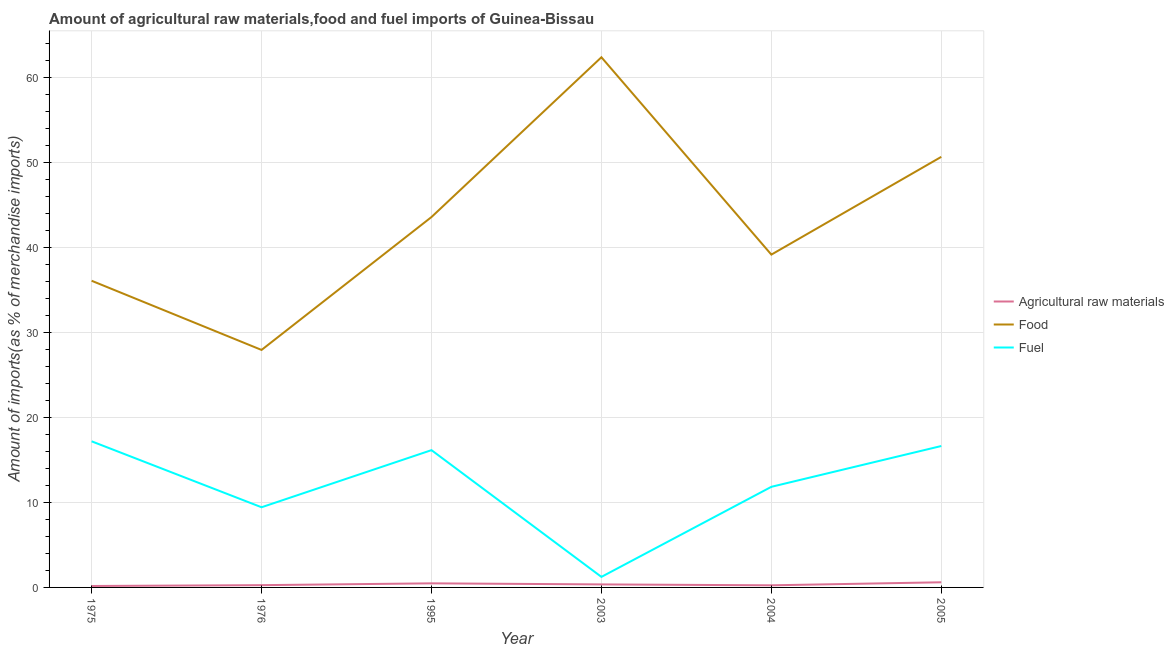How many different coloured lines are there?
Offer a terse response. 3. What is the percentage of food imports in 2004?
Make the answer very short. 39.18. Across all years, what is the maximum percentage of raw materials imports?
Ensure brevity in your answer.  0.61. Across all years, what is the minimum percentage of raw materials imports?
Make the answer very short. 0.17. What is the total percentage of food imports in the graph?
Your response must be concise. 259.96. What is the difference between the percentage of food imports in 1976 and that in 2004?
Offer a very short reply. -11.22. What is the difference between the percentage of fuel imports in 2005 and the percentage of raw materials imports in 1976?
Your response must be concise. 16.38. What is the average percentage of raw materials imports per year?
Give a very brief answer. 0.35. In the year 2003, what is the difference between the percentage of raw materials imports and percentage of fuel imports?
Provide a succinct answer. -0.89. In how many years, is the percentage of raw materials imports greater than 10 %?
Your answer should be compact. 0. What is the ratio of the percentage of raw materials imports in 1975 to that in 2003?
Offer a very short reply. 0.48. Is the percentage of fuel imports in 1976 less than that in 2004?
Offer a terse response. Yes. Is the difference between the percentage of raw materials imports in 1976 and 2004 greater than the difference between the percentage of fuel imports in 1976 and 2004?
Make the answer very short. Yes. What is the difference between the highest and the second highest percentage of food imports?
Provide a short and direct response. 11.72. What is the difference between the highest and the lowest percentage of fuel imports?
Your answer should be very brief. 15.96. Is it the case that in every year, the sum of the percentage of raw materials imports and percentage of food imports is greater than the percentage of fuel imports?
Offer a terse response. Yes. How many years are there in the graph?
Keep it short and to the point. 6. Are the values on the major ticks of Y-axis written in scientific E-notation?
Your answer should be compact. No. Does the graph contain grids?
Make the answer very short. Yes. How many legend labels are there?
Provide a succinct answer. 3. How are the legend labels stacked?
Your answer should be very brief. Vertical. What is the title of the graph?
Keep it short and to the point. Amount of agricultural raw materials,food and fuel imports of Guinea-Bissau. What is the label or title of the X-axis?
Offer a terse response. Year. What is the label or title of the Y-axis?
Keep it short and to the point. Amount of imports(as % of merchandise imports). What is the Amount of imports(as % of merchandise imports) in Agricultural raw materials in 1975?
Offer a very short reply. 0.17. What is the Amount of imports(as % of merchandise imports) of Food in 1975?
Keep it short and to the point. 36.1. What is the Amount of imports(as % of merchandise imports) in Fuel in 1975?
Offer a very short reply. 17.2. What is the Amount of imports(as % of merchandise imports) of Agricultural raw materials in 1976?
Provide a short and direct response. 0.27. What is the Amount of imports(as % of merchandise imports) of Food in 1976?
Provide a short and direct response. 27.96. What is the Amount of imports(as % of merchandise imports) in Fuel in 1976?
Make the answer very short. 9.44. What is the Amount of imports(as % of merchandise imports) of Agricultural raw materials in 1995?
Provide a succinct answer. 0.48. What is the Amount of imports(as % of merchandise imports) in Food in 1995?
Ensure brevity in your answer.  43.6. What is the Amount of imports(as % of merchandise imports) of Fuel in 1995?
Provide a short and direct response. 16.16. What is the Amount of imports(as % of merchandise imports) of Agricultural raw materials in 2003?
Give a very brief answer. 0.36. What is the Amount of imports(as % of merchandise imports) in Food in 2003?
Make the answer very short. 62.42. What is the Amount of imports(as % of merchandise imports) of Fuel in 2003?
Provide a succinct answer. 1.24. What is the Amount of imports(as % of merchandise imports) of Agricultural raw materials in 2004?
Offer a terse response. 0.25. What is the Amount of imports(as % of merchandise imports) of Food in 2004?
Offer a very short reply. 39.18. What is the Amount of imports(as % of merchandise imports) of Fuel in 2004?
Give a very brief answer. 11.84. What is the Amount of imports(as % of merchandise imports) of Agricultural raw materials in 2005?
Your answer should be compact. 0.61. What is the Amount of imports(as % of merchandise imports) in Food in 2005?
Provide a succinct answer. 50.69. What is the Amount of imports(as % of merchandise imports) of Fuel in 2005?
Give a very brief answer. 16.65. Across all years, what is the maximum Amount of imports(as % of merchandise imports) in Agricultural raw materials?
Offer a very short reply. 0.61. Across all years, what is the maximum Amount of imports(as % of merchandise imports) in Food?
Your answer should be compact. 62.42. Across all years, what is the maximum Amount of imports(as % of merchandise imports) in Fuel?
Offer a terse response. 17.2. Across all years, what is the minimum Amount of imports(as % of merchandise imports) of Agricultural raw materials?
Provide a succinct answer. 0.17. Across all years, what is the minimum Amount of imports(as % of merchandise imports) of Food?
Make the answer very short. 27.96. Across all years, what is the minimum Amount of imports(as % of merchandise imports) in Fuel?
Ensure brevity in your answer.  1.24. What is the total Amount of imports(as % of merchandise imports) of Agricultural raw materials in the graph?
Your answer should be very brief. 2.13. What is the total Amount of imports(as % of merchandise imports) of Food in the graph?
Your response must be concise. 259.96. What is the total Amount of imports(as % of merchandise imports) of Fuel in the graph?
Provide a short and direct response. 72.54. What is the difference between the Amount of imports(as % of merchandise imports) of Agricultural raw materials in 1975 and that in 1976?
Offer a terse response. -0.1. What is the difference between the Amount of imports(as % of merchandise imports) in Food in 1975 and that in 1976?
Your answer should be very brief. 8.14. What is the difference between the Amount of imports(as % of merchandise imports) of Fuel in 1975 and that in 1976?
Your answer should be compact. 7.76. What is the difference between the Amount of imports(as % of merchandise imports) in Agricultural raw materials in 1975 and that in 1995?
Your answer should be compact. -0.31. What is the difference between the Amount of imports(as % of merchandise imports) in Food in 1975 and that in 1995?
Provide a succinct answer. -7.5. What is the difference between the Amount of imports(as % of merchandise imports) of Fuel in 1975 and that in 1995?
Ensure brevity in your answer.  1.04. What is the difference between the Amount of imports(as % of merchandise imports) in Agricultural raw materials in 1975 and that in 2003?
Offer a very short reply. -0.19. What is the difference between the Amount of imports(as % of merchandise imports) in Food in 1975 and that in 2003?
Your response must be concise. -26.31. What is the difference between the Amount of imports(as % of merchandise imports) of Fuel in 1975 and that in 2003?
Offer a very short reply. 15.96. What is the difference between the Amount of imports(as % of merchandise imports) of Agricultural raw materials in 1975 and that in 2004?
Provide a succinct answer. -0.08. What is the difference between the Amount of imports(as % of merchandise imports) in Food in 1975 and that in 2004?
Give a very brief answer. -3.08. What is the difference between the Amount of imports(as % of merchandise imports) in Fuel in 1975 and that in 2004?
Provide a short and direct response. 5.36. What is the difference between the Amount of imports(as % of merchandise imports) of Agricultural raw materials in 1975 and that in 2005?
Keep it short and to the point. -0.44. What is the difference between the Amount of imports(as % of merchandise imports) of Food in 1975 and that in 2005?
Keep it short and to the point. -14.59. What is the difference between the Amount of imports(as % of merchandise imports) in Fuel in 1975 and that in 2005?
Keep it short and to the point. 0.55. What is the difference between the Amount of imports(as % of merchandise imports) of Agricultural raw materials in 1976 and that in 1995?
Offer a terse response. -0.21. What is the difference between the Amount of imports(as % of merchandise imports) in Food in 1976 and that in 1995?
Provide a short and direct response. -15.64. What is the difference between the Amount of imports(as % of merchandise imports) in Fuel in 1976 and that in 1995?
Provide a succinct answer. -6.72. What is the difference between the Amount of imports(as % of merchandise imports) in Agricultural raw materials in 1976 and that in 2003?
Provide a succinct answer. -0.09. What is the difference between the Amount of imports(as % of merchandise imports) of Food in 1976 and that in 2003?
Offer a very short reply. -34.46. What is the difference between the Amount of imports(as % of merchandise imports) in Fuel in 1976 and that in 2003?
Your answer should be very brief. 8.2. What is the difference between the Amount of imports(as % of merchandise imports) in Agricultural raw materials in 1976 and that in 2004?
Ensure brevity in your answer.  0.02. What is the difference between the Amount of imports(as % of merchandise imports) of Food in 1976 and that in 2004?
Keep it short and to the point. -11.22. What is the difference between the Amount of imports(as % of merchandise imports) in Fuel in 1976 and that in 2004?
Offer a terse response. -2.41. What is the difference between the Amount of imports(as % of merchandise imports) of Agricultural raw materials in 1976 and that in 2005?
Ensure brevity in your answer.  -0.34. What is the difference between the Amount of imports(as % of merchandise imports) in Food in 1976 and that in 2005?
Make the answer very short. -22.73. What is the difference between the Amount of imports(as % of merchandise imports) of Fuel in 1976 and that in 2005?
Keep it short and to the point. -7.21. What is the difference between the Amount of imports(as % of merchandise imports) in Agricultural raw materials in 1995 and that in 2003?
Your response must be concise. 0.13. What is the difference between the Amount of imports(as % of merchandise imports) of Food in 1995 and that in 2003?
Make the answer very short. -18.81. What is the difference between the Amount of imports(as % of merchandise imports) of Fuel in 1995 and that in 2003?
Offer a very short reply. 14.92. What is the difference between the Amount of imports(as % of merchandise imports) of Agricultural raw materials in 1995 and that in 2004?
Keep it short and to the point. 0.23. What is the difference between the Amount of imports(as % of merchandise imports) in Food in 1995 and that in 2004?
Your answer should be very brief. 4.42. What is the difference between the Amount of imports(as % of merchandise imports) of Fuel in 1995 and that in 2004?
Your answer should be compact. 4.32. What is the difference between the Amount of imports(as % of merchandise imports) in Agricultural raw materials in 1995 and that in 2005?
Ensure brevity in your answer.  -0.13. What is the difference between the Amount of imports(as % of merchandise imports) of Food in 1995 and that in 2005?
Provide a succinct answer. -7.09. What is the difference between the Amount of imports(as % of merchandise imports) in Fuel in 1995 and that in 2005?
Keep it short and to the point. -0.49. What is the difference between the Amount of imports(as % of merchandise imports) in Agricultural raw materials in 2003 and that in 2004?
Ensure brevity in your answer.  0.11. What is the difference between the Amount of imports(as % of merchandise imports) of Food in 2003 and that in 2004?
Make the answer very short. 23.23. What is the difference between the Amount of imports(as % of merchandise imports) in Fuel in 2003 and that in 2004?
Provide a succinct answer. -10.6. What is the difference between the Amount of imports(as % of merchandise imports) in Agricultural raw materials in 2003 and that in 2005?
Give a very brief answer. -0.25. What is the difference between the Amount of imports(as % of merchandise imports) in Food in 2003 and that in 2005?
Your answer should be very brief. 11.72. What is the difference between the Amount of imports(as % of merchandise imports) in Fuel in 2003 and that in 2005?
Offer a very short reply. -15.41. What is the difference between the Amount of imports(as % of merchandise imports) of Agricultural raw materials in 2004 and that in 2005?
Make the answer very short. -0.36. What is the difference between the Amount of imports(as % of merchandise imports) in Food in 2004 and that in 2005?
Give a very brief answer. -11.51. What is the difference between the Amount of imports(as % of merchandise imports) in Fuel in 2004 and that in 2005?
Provide a succinct answer. -4.8. What is the difference between the Amount of imports(as % of merchandise imports) of Agricultural raw materials in 1975 and the Amount of imports(as % of merchandise imports) of Food in 1976?
Your response must be concise. -27.79. What is the difference between the Amount of imports(as % of merchandise imports) in Agricultural raw materials in 1975 and the Amount of imports(as % of merchandise imports) in Fuel in 1976?
Give a very brief answer. -9.27. What is the difference between the Amount of imports(as % of merchandise imports) of Food in 1975 and the Amount of imports(as % of merchandise imports) of Fuel in 1976?
Give a very brief answer. 26.67. What is the difference between the Amount of imports(as % of merchandise imports) in Agricultural raw materials in 1975 and the Amount of imports(as % of merchandise imports) in Food in 1995?
Give a very brief answer. -43.44. What is the difference between the Amount of imports(as % of merchandise imports) in Agricultural raw materials in 1975 and the Amount of imports(as % of merchandise imports) in Fuel in 1995?
Keep it short and to the point. -15.99. What is the difference between the Amount of imports(as % of merchandise imports) of Food in 1975 and the Amount of imports(as % of merchandise imports) of Fuel in 1995?
Give a very brief answer. 19.94. What is the difference between the Amount of imports(as % of merchandise imports) of Agricultural raw materials in 1975 and the Amount of imports(as % of merchandise imports) of Food in 2003?
Your response must be concise. -62.25. What is the difference between the Amount of imports(as % of merchandise imports) of Agricultural raw materials in 1975 and the Amount of imports(as % of merchandise imports) of Fuel in 2003?
Provide a succinct answer. -1.07. What is the difference between the Amount of imports(as % of merchandise imports) of Food in 1975 and the Amount of imports(as % of merchandise imports) of Fuel in 2003?
Provide a succinct answer. 34.86. What is the difference between the Amount of imports(as % of merchandise imports) of Agricultural raw materials in 1975 and the Amount of imports(as % of merchandise imports) of Food in 2004?
Keep it short and to the point. -39.01. What is the difference between the Amount of imports(as % of merchandise imports) of Agricultural raw materials in 1975 and the Amount of imports(as % of merchandise imports) of Fuel in 2004?
Offer a terse response. -11.68. What is the difference between the Amount of imports(as % of merchandise imports) in Food in 1975 and the Amount of imports(as % of merchandise imports) in Fuel in 2004?
Keep it short and to the point. 24.26. What is the difference between the Amount of imports(as % of merchandise imports) in Agricultural raw materials in 1975 and the Amount of imports(as % of merchandise imports) in Food in 2005?
Offer a very short reply. -50.52. What is the difference between the Amount of imports(as % of merchandise imports) of Agricultural raw materials in 1975 and the Amount of imports(as % of merchandise imports) of Fuel in 2005?
Your answer should be compact. -16.48. What is the difference between the Amount of imports(as % of merchandise imports) in Food in 1975 and the Amount of imports(as % of merchandise imports) in Fuel in 2005?
Offer a very short reply. 19.46. What is the difference between the Amount of imports(as % of merchandise imports) of Agricultural raw materials in 1976 and the Amount of imports(as % of merchandise imports) of Food in 1995?
Your response must be concise. -43.34. What is the difference between the Amount of imports(as % of merchandise imports) in Agricultural raw materials in 1976 and the Amount of imports(as % of merchandise imports) in Fuel in 1995?
Your answer should be compact. -15.89. What is the difference between the Amount of imports(as % of merchandise imports) in Food in 1976 and the Amount of imports(as % of merchandise imports) in Fuel in 1995?
Your answer should be compact. 11.8. What is the difference between the Amount of imports(as % of merchandise imports) in Agricultural raw materials in 1976 and the Amount of imports(as % of merchandise imports) in Food in 2003?
Your answer should be compact. -62.15. What is the difference between the Amount of imports(as % of merchandise imports) in Agricultural raw materials in 1976 and the Amount of imports(as % of merchandise imports) in Fuel in 2003?
Provide a short and direct response. -0.97. What is the difference between the Amount of imports(as % of merchandise imports) of Food in 1976 and the Amount of imports(as % of merchandise imports) of Fuel in 2003?
Your response must be concise. 26.72. What is the difference between the Amount of imports(as % of merchandise imports) of Agricultural raw materials in 1976 and the Amount of imports(as % of merchandise imports) of Food in 2004?
Ensure brevity in your answer.  -38.91. What is the difference between the Amount of imports(as % of merchandise imports) of Agricultural raw materials in 1976 and the Amount of imports(as % of merchandise imports) of Fuel in 2004?
Your answer should be very brief. -11.58. What is the difference between the Amount of imports(as % of merchandise imports) of Food in 1976 and the Amount of imports(as % of merchandise imports) of Fuel in 2004?
Your answer should be compact. 16.12. What is the difference between the Amount of imports(as % of merchandise imports) of Agricultural raw materials in 1976 and the Amount of imports(as % of merchandise imports) of Food in 2005?
Your response must be concise. -50.42. What is the difference between the Amount of imports(as % of merchandise imports) in Agricultural raw materials in 1976 and the Amount of imports(as % of merchandise imports) in Fuel in 2005?
Offer a very short reply. -16.38. What is the difference between the Amount of imports(as % of merchandise imports) in Food in 1976 and the Amount of imports(as % of merchandise imports) in Fuel in 2005?
Provide a short and direct response. 11.31. What is the difference between the Amount of imports(as % of merchandise imports) in Agricultural raw materials in 1995 and the Amount of imports(as % of merchandise imports) in Food in 2003?
Make the answer very short. -61.94. What is the difference between the Amount of imports(as % of merchandise imports) of Agricultural raw materials in 1995 and the Amount of imports(as % of merchandise imports) of Fuel in 2003?
Offer a terse response. -0.76. What is the difference between the Amount of imports(as % of merchandise imports) in Food in 1995 and the Amount of imports(as % of merchandise imports) in Fuel in 2003?
Keep it short and to the point. 42.36. What is the difference between the Amount of imports(as % of merchandise imports) in Agricultural raw materials in 1995 and the Amount of imports(as % of merchandise imports) in Food in 2004?
Make the answer very short. -38.7. What is the difference between the Amount of imports(as % of merchandise imports) in Agricultural raw materials in 1995 and the Amount of imports(as % of merchandise imports) in Fuel in 2004?
Ensure brevity in your answer.  -11.36. What is the difference between the Amount of imports(as % of merchandise imports) in Food in 1995 and the Amount of imports(as % of merchandise imports) in Fuel in 2004?
Offer a very short reply. 31.76. What is the difference between the Amount of imports(as % of merchandise imports) in Agricultural raw materials in 1995 and the Amount of imports(as % of merchandise imports) in Food in 2005?
Your response must be concise. -50.21. What is the difference between the Amount of imports(as % of merchandise imports) in Agricultural raw materials in 1995 and the Amount of imports(as % of merchandise imports) in Fuel in 2005?
Your answer should be compact. -16.17. What is the difference between the Amount of imports(as % of merchandise imports) in Food in 1995 and the Amount of imports(as % of merchandise imports) in Fuel in 2005?
Your answer should be very brief. 26.96. What is the difference between the Amount of imports(as % of merchandise imports) of Agricultural raw materials in 2003 and the Amount of imports(as % of merchandise imports) of Food in 2004?
Your response must be concise. -38.83. What is the difference between the Amount of imports(as % of merchandise imports) in Agricultural raw materials in 2003 and the Amount of imports(as % of merchandise imports) in Fuel in 2004?
Provide a succinct answer. -11.49. What is the difference between the Amount of imports(as % of merchandise imports) of Food in 2003 and the Amount of imports(as % of merchandise imports) of Fuel in 2004?
Keep it short and to the point. 50.57. What is the difference between the Amount of imports(as % of merchandise imports) of Agricultural raw materials in 2003 and the Amount of imports(as % of merchandise imports) of Food in 2005?
Make the answer very short. -50.34. What is the difference between the Amount of imports(as % of merchandise imports) of Agricultural raw materials in 2003 and the Amount of imports(as % of merchandise imports) of Fuel in 2005?
Provide a short and direct response. -16.29. What is the difference between the Amount of imports(as % of merchandise imports) in Food in 2003 and the Amount of imports(as % of merchandise imports) in Fuel in 2005?
Ensure brevity in your answer.  45.77. What is the difference between the Amount of imports(as % of merchandise imports) of Agricultural raw materials in 2004 and the Amount of imports(as % of merchandise imports) of Food in 2005?
Make the answer very short. -50.44. What is the difference between the Amount of imports(as % of merchandise imports) of Agricultural raw materials in 2004 and the Amount of imports(as % of merchandise imports) of Fuel in 2005?
Give a very brief answer. -16.4. What is the difference between the Amount of imports(as % of merchandise imports) in Food in 2004 and the Amount of imports(as % of merchandise imports) in Fuel in 2005?
Provide a short and direct response. 22.53. What is the average Amount of imports(as % of merchandise imports) in Agricultural raw materials per year?
Make the answer very short. 0.35. What is the average Amount of imports(as % of merchandise imports) of Food per year?
Provide a short and direct response. 43.33. What is the average Amount of imports(as % of merchandise imports) of Fuel per year?
Make the answer very short. 12.09. In the year 1975, what is the difference between the Amount of imports(as % of merchandise imports) in Agricultural raw materials and Amount of imports(as % of merchandise imports) in Food?
Your answer should be very brief. -35.94. In the year 1975, what is the difference between the Amount of imports(as % of merchandise imports) of Agricultural raw materials and Amount of imports(as % of merchandise imports) of Fuel?
Keep it short and to the point. -17.03. In the year 1975, what is the difference between the Amount of imports(as % of merchandise imports) of Food and Amount of imports(as % of merchandise imports) of Fuel?
Ensure brevity in your answer.  18.9. In the year 1976, what is the difference between the Amount of imports(as % of merchandise imports) of Agricultural raw materials and Amount of imports(as % of merchandise imports) of Food?
Your answer should be compact. -27.69. In the year 1976, what is the difference between the Amount of imports(as % of merchandise imports) of Agricultural raw materials and Amount of imports(as % of merchandise imports) of Fuel?
Offer a terse response. -9.17. In the year 1976, what is the difference between the Amount of imports(as % of merchandise imports) in Food and Amount of imports(as % of merchandise imports) in Fuel?
Give a very brief answer. 18.52. In the year 1995, what is the difference between the Amount of imports(as % of merchandise imports) in Agricultural raw materials and Amount of imports(as % of merchandise imports) in Food?
Your answer should be very brief. -43.12. In the year 1995, what is the difference between the Amount of imports(as % of merchandise imports) in Agricultural raw materials and Amount of imports(as % of merchandise imports) in Fuel?
Give a very brief answer. -15.68. In the year 1995, what is the difference between the Amount of imports(as % of merchandise imports) in Food and Amount of imports(as % of merchandise imports) in Fuel?
Your answer should be very brief. 27.44. In the year 2003, what is the difference between the Amount of imports(as % of merchandise imports) in Agricultural raw materials and Amount of imports(as % of merchandise imports) in Food?
Offer a terse response. -62.06. In the year 2003, what is the difference between the Amount of imports(as % of merchandise imports) of Agricultural raw materials and Amount of imports(as % of merchandise imports) of Fuel?
Your answer should be very brief. -0.89. In the year 2003, what is the difference between the Amount of imports(as % of merchandise imports) in Food and Amount of imports(as % of merchandise imports) in Fuel?
Provide a short and direct response. 61.17. In the year 2004, what is the difference between the Amount of imports(as % of merchandise imports) in Agricultural raw materials and Amount of imports(as % of merchandise imports) in Food?
Ensure brevity in your answer.  -38.93. In the year 2004, what is the difference between the Amount of imports(as % of merchandise imports) of Agricultural raw materials and Amount of imports(as % of merchandise imports) of Fuel?
Make the answer very short. -11.6. In the year 2004, what is the difference between the Amount of imports(as % of merchandise imports) in Food and Amount of imports(as % of merchandise imports) in Fuel?
Ensure brevity in your answer.  27.34. In the year 2005, what is the difference between the Amount of imports(as % of merchandise imports) in Agricultural raw materials and Amount of imports(as % of merchandise imports) in Food?
Provide a succinct answer. -50.09. In the year 2005, what is the difference between the Amount of imports(as % of merchandise imports) of Agricultural raw materials and Amount of imports(as % of merchandise imports) of Fuel?
Your answer should be very brief. -16.04. In the year 2005, what is the difference between the Amount of imports(as % of merchandise imports) of Food and Amount of imports(as % of merchandise imports) of Fuel?
Your answer should be very brief. 34.04. What is the ratio of the Amount of imports(as % of merchandise imports) of Agricultural raw materials in 1975 to that in 1976?
Offer a terse response. 0.63. What is the ratio of the Amount of imports(as % of merchandise imports) of Food in 1975 to that in 1976?
Keep it short and to the point. 1.29. What is the ratio of the Amount of imports(as % of merchandise imports) in Fuel in 1975 to that in 1976?
Offer a terse response. 1.82. What is the ratio of the Amount of imports(as % of merchandise imports) of Agricultural raw materials in 1975 to that in 1995?
Make the answer very short. 0.35. What is the ratio of the Amount of imports(as % of merchandise imports) in Food in 1975 to that in 1995?
Your answer should be very brief. 0.83. What is the ratio of the Amount of imports(as % of merchandise imports) in Fuel in 1975 to that in 1995?
Ensure brevity in your answer.  1.06. What is the ratio of the Amount of imports(as % of merchandise imports) of Agricultural raw materials in 1975 to that in 2003?
Provide a succinct answer. 0.48. What is the ratio of the Amount of imports(as % of merchandise imports) in Food in 1975 to that in 2003?
Your response must be concise. 0.58. What is the ratio of the Amount of imports(as % of merchandise imports) in Fuel in 1975 to that in 2003?
Your response must be concise. 13.85. What is the ratio of the Amount of imports(as % of merchandise imports) of Agricultural raw materials in 1975 to that in 2004?
Ensure brevity in your answer.  0.68. What is the ratio of the Amount of imports(as % of merchandise imports) in Food in 1975 to that in 2004?
Provide a short and direct response. 0.92. What is the ratio of the Amount of imports(as % of merchandise imports) of Fuel in 1975 to that in 2004?
Your response must be concise. 1.45. What is the ratio of the Amount of imports(as % of merchandise imports) in Agricultural raw materials in 1975 to that in 2005?
Your response must be concise. 0.28. What is the ratio of the Amount of imports(as % of merchandise imports) of Food in 1975 to that in 2005?
Keep it short and to the point. 0.71. What is the ratio of the Amount of imports(as % of merchandise imports) in Agricultural raw materials in 1976 to that in 1995?
Ensure brevity in your answer.  0.56. What is the ratio of the Amount of imports(as % of merchandise imports) in Food in 1976 to that in 1995?
Offer a terse response. 0.64. What is the ratio of the Amount of imports(as % of merchandise imports) of Fuel in 1976 to that in 1995?
Keep it short and to the point. 0.58. What is the ratio of the Amount of imports(as % of merchandise imports) of Agricultural raw materials in 1976 to that in 2003?
Provide a succinct answer. 0.75. What is the ratio of the Amount of imports(as % of merchandise imports) of Food in 1976 to that in 2003?
Your answer should be very brief. 0.45. What is the ratio of the Amount of imports(as % of merchandise imports) of Fuel in 1976 to that in 2003?
Provide a short and direct response. 7.6. What is the ratio of the Amount of imports(as % of merchandise imports) in Agricultural raw materials in 1976 to that in 2004?
Offer a terse response. 1.07. What is the ratio of the Amount of imports(as % of merchandise imports) in Food in 1976 to that in 2004?
Offer a terse response. 0.71. What is the ratio of the Amount of imports(as % of merchandise imports) in Fuel in 1976 to that in 2004?
Ensure brevity in your answer.  0.8. What is the ratio of the Amount of imports(as % of merchandise imports) in Agricultural raw materials in 1976 to that in 2005?
Offer a very short reply. 0.44. What is the ratio of the Amount of imports(as % of merchandise imports) of Food in 1976 to that in 2005?
Provide a succinct answer. 0.55. What is the ratio of the Amount of imports(as % of merchandise imports) of Fuel in 1976 to that in 2005?
Keep it short and to the point. 0.57. What is the ratio of the Amount of imports(as % of merchandise imports) in Agricultural raw materials in 1995 to that in 2003?
Your answer should be compact. 1.35. What is the ratio of the Amount of imports(as % of merchandise imports) in Food in 1995 to that in 2003?
Give a very brief answer. 0.7. What is the ratio of the Amount of imports(as % of merchandise imports) of Fuel in 1995 to that in 2003?
Your answer should be compact. 13.02. What is the ratio of the Amount of imports(as % of merchandise imports) in Agricultural raw materials in 1995 to that in 2004?
Ensure brevity in your answer.  1.93. What is the ratio of the Amount of imports(as % of merchandise imports) in Food in 1995 to that in 2004?
Ensure brevity in your answer.  1.11. What is the ratio of the Amount of imports(as % of merchandise imports) in Fuel in 1995 to that in 2004?
Ensure brevity in your answer.  1.36. What is the ratio of the Amount of imports(as % of merchandise imports) of Agricultural raw materials in 1995 to that in 2005?
Ensure brevity in your answer.  0.79. What is the ratio of the Amount of imports(as % of merchandise imports) of Food in 1995 to that in 2005?
Keep it short and to the point. 0.86. What is the ratio of the Amount of imports(as % of merchandise imports) in Fuel in 1995 to that in 2005?
Keep it short and to the point. 0.97. What is the ratio of the Amount of imports(as % of merchandise imports) of Agricultural raw materials in 2003 to that in 2004?
Ensure brevity in your answer.  1.43. What is the ratio of the Amount of imports(as % of merchandise imports) of Food in 2003 to that in 2004?
Offer a terse response. 1.59. What is the ratio of the Amount of imports(as % of merchandise imports) in Fuel in 2003 to that in 2004?
Make the answer very short. 0.1. What is the ratio of the Amount of imports(as % of merchandise imports) in Agricultural raw materials in 2003 to that in 2005?
Give a very brief answer. 0.59. What is the ratio of the Amount of imports(as % of merchandise imports) of Food in 2003 to that in 2005?
Give a very brief answer. 1.23. What is the ratio of the Amount of imports(as % of merchandise imports) in Fuel in 2003 to that in 2005?
Your response must be concise. 0.07. What is the ratio of the Amount of imports(as % of merchandise imports) in Agricultural raw materials in 2004 to that in 2005?
Offer a terse response. 0.41. What is the ratio of the Amount of imports(as % of merchandise imports) in Food in 2004 to that in 2005?
Provide a short and direct response. 0.77. What is the ratio of the Amount of imports(as % of merchandise imports) in Fuel in 2004 to that in 2005?
Offer a terse response. 0.71. What is the difference between the highest and the second highest Amount of imports(as % of merchandise imports) in Agricultural raw materials?
Provide a succinct answer. 0.13. What is the difference between the highest and the second highest Amount of imports(as % of merchandise imports) of Food?
Your answer should be compact. 11.72. What is the difference between the highest and the second highest Amount of imports(as % of merchandise imports) of Fuel?
Make the answer very short. 0.55. What is the difference between the highest and the lowest Amount of imports(as % of merchandise imports) in Agricultural raw materials?
Provide a short and direct response. 0.44. What is the difference between the highest and the lowest Amount of imports(as % of merchandise imports) of Food?
Ensure brevity in your answer.  34.46. What is the difference between the highest and the lowest Amount of imports(as % of merchandise imports) of Fuel?
Make the answer very short. 15.96. 